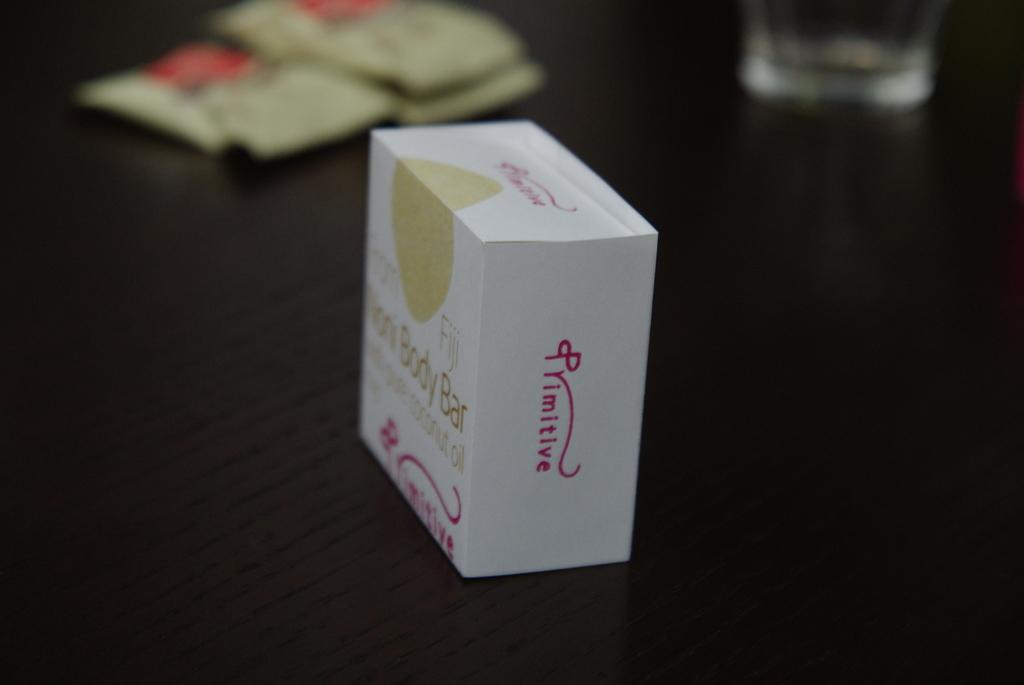<image>
Present a compact description of the photo's key features. A small boxed body bar on a table or nightstand made by primitive. 